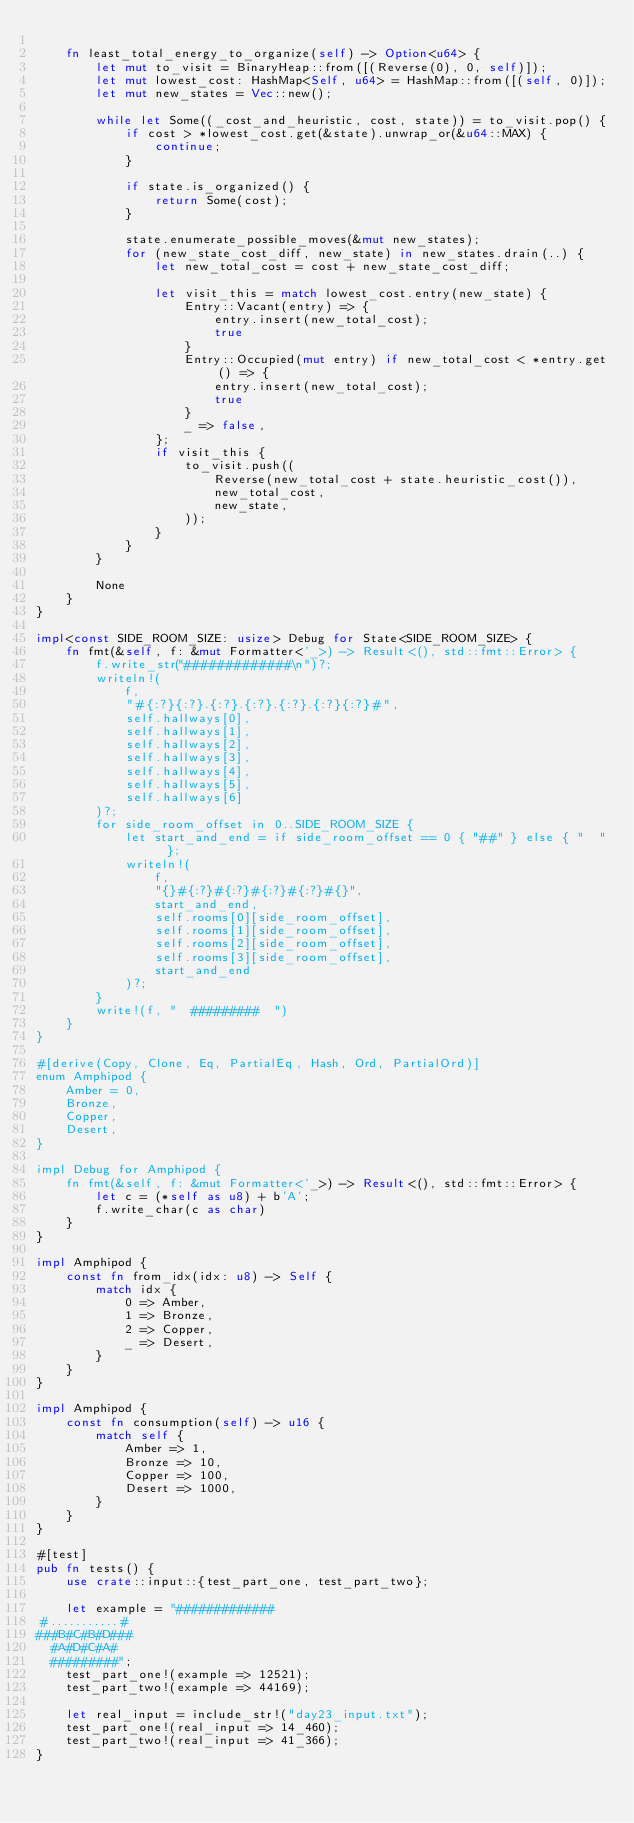Convert code to text. <code><loc_0><loc_0><loc_500><loc_500><_Rust_>
    fn least_total_energy_to_organize(self) -> Option<u64> {
        let mut to_visit = BinaryHeap::from([(Reverse(0), 0, self)]);
        let mut lowest_cost: HashMap<Self, u64> = HashMap::from([(self, 0)]);
        let mut new_states = Vec::new();

        while let Some((_cost_and_heuristic, cost, state)) = to_visit.pop() {
            if cost > *lowest_cost.get(&state).unwrap_or(&u64::MAX) {
                continue;
            }

            if state.is_organized() {
                return Some(cost);
            }

            state.enumerate_possible_moves(&mut new_states);
            for (new_state_cost_diff, new_state) in new_states.drain(..) {
                let new_total_cost = cost + new_state_cost_diff;

                let visit_this = match lowest_cost.entry(new_state) {
                    Entry::Vacant(entry) => {
                        entry.insert(new_total_cost);
                        true
                    }
                    Entry::Occupied(mut entry) if new_total_cost < *entry.get() => {
                        entry.insert(new_total_cost);
                        true
                    }
                    _ => false,
                };
                if visit_this {
                    to_visit.push((
                        Reverse(new_total_cost + state.heuristic_cost()),
                        new_total_cost,
                        new_state,
                    ));
                }
            }
        }

        None
    }
}

impl<const SIDE_ROOM_SIZE: usize> Debug for State<SIDE_ROOM_SIZE> {
    fn fmt(&self, f: &mut Formatter<'_>) -> Result<(), std::fmt::Error> {
        f.write_str("#############\n")?;
        writeln!(
            f,
            "#{:?}{:?}.{:?}.{:?}.{:?}.{:?}{:?}#",
            self.hallways[0],
            self.hallways[1],
            self.hallways[2],
            self.hallways[3],
            self.hallways[4],
            self.hallways[5],
            self.hallways[6]
        )?;
        for side_room_offset in 0..SIDE_ROOM_SIZE {
            let start_and_end = if side_room_offset == 0 { "##" } else { "  " };
            writeln!(
                f,
                "{}#{:?}#{:?}#{:?}#{:?}#{}",
                start_and_end,
                self.rooms[0][side_room_offset],
                self.rooms[1][side_room_offset],
                self.rooms[2][side_room_offset],
                self.rooms[3][side_room_offset],
                start_and_end
            )?;
        }
        write!(f, "  #########  ")
    }
}

#[derive(Copy, Clone, Eq, PartialEq, Hash, Ord, PartialOrd)]
enum Amphipod {
    Amber = 0,
    Bronze,
    Copper,
    Desert,
}

impl Debug for Amphipod {
    fn fmt(&self, f: &mut Formatter<'_>) -> Result<(), std::fmt::Error> {
        let c = (*self as u8) + b'A';
        f.write_char(c as char)
    }
}

impl Amphipod {
    const fn from_idx(idx: u8) -> Self {
        match idx {
            0 => Amber,
            1 => Bronze,
            2 => Copper,
            _ => Desert,
        }
    }
}

impl Amphipod {
    const fn consumption(self) -> u16 {
        match self {
            Amber => 1,
            Bronze => 10,
            Copper => 100,
            Desert => 1000,
        }
    }
}

#[test]
pub fn tests() {
    use crate::input::{test_part_one, test_part_two};

    let example = "#############
#...........#
###B#C#B#D###
  #A#D#C#A#
  #########";
    test_part_one!(example => 12521);
    test_part_two!(example => 44169);

    let real_input = include_str!("day23_input.txt");
    test_part_one!(real_input => 14_460);
    test_part_two!(real_input => 41_366);
}
</code> 